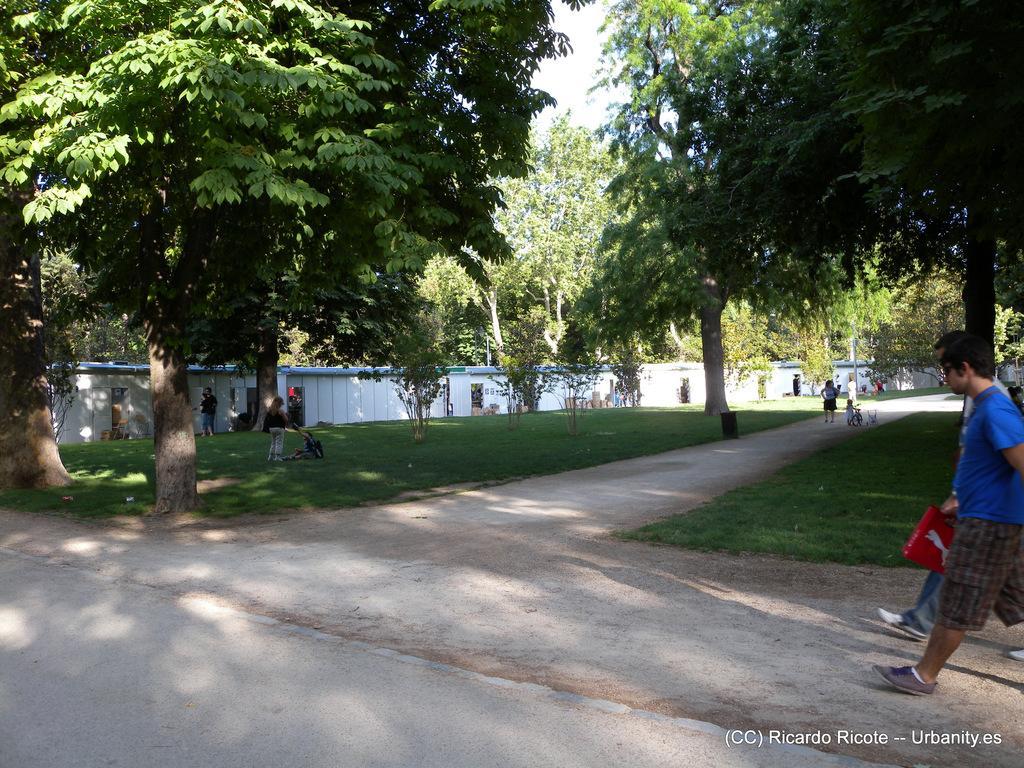In one or two sentences, can you explain what this image depicts? In this picture I can see trees and grass and a wall on the side and I can see few people standing and couple of them walking and a man holding a bag in his hand and I can see a kid holding a bicycle and a cloudy sky and I can see text at bottom right corner of the picture. 